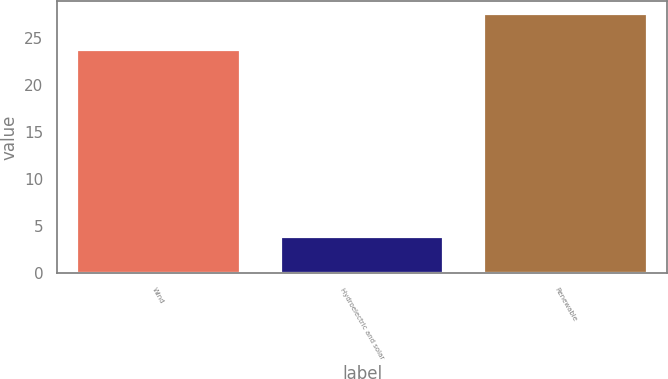Convert chart. <chart><loc_0><loc_0><loc_500><loc_500><bar_chart><fcel>Wind<fcel>Hydroelectric and solar<fcel>Renewable<nl><fcel>23.7<fcel>3.9<fcel>27.6<nl></chart> 